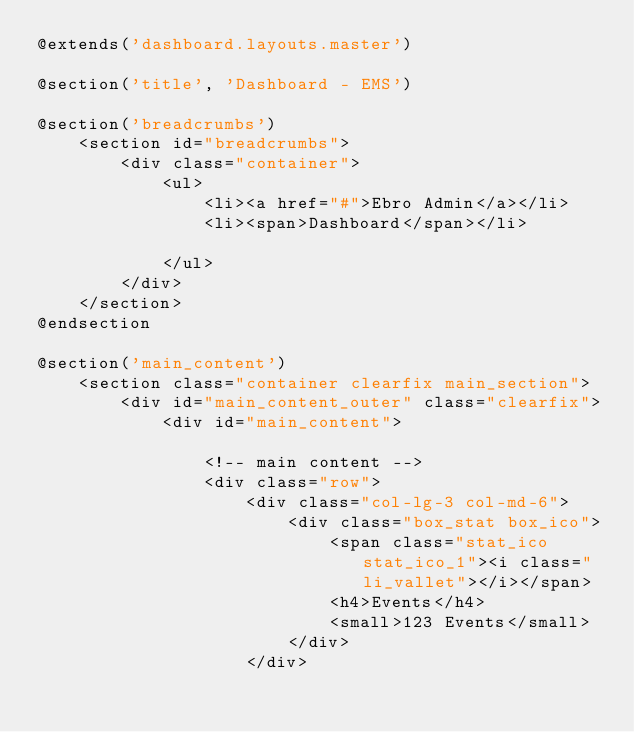Convert code to text. <code><loc_0><loc_0><loc_500><loc_500><_PHP_>@extends('dashboard.layouts.master')

@section('title', 'Dashboard - EMS')

@section('breadcrumbs')
	<section id="breadcrumbs">
		<div class="container">
			<ul>
				<li><a href="#">Ebro Admin</a></li>
				<li><span>Dashboard</span></li>						
			</ul>
		</div>
	</section>
@endsection

@section('main_content')
	<section class="container clearfix main_section">
		<div id="main_content_outer" class="clearfix">
			<div id="main_content">
				
				<!-- main content -->
				<div class="row">
					<div class="col-lg-3 col-md-6">
						<div class="box_stat box_ico">
							<span class="stat_ico stat_ico_1"><i class="li_vallet"></i></span>
							<h4>Events</h4>
							<small>123 Events</small>
						</div>
					</div></code> 